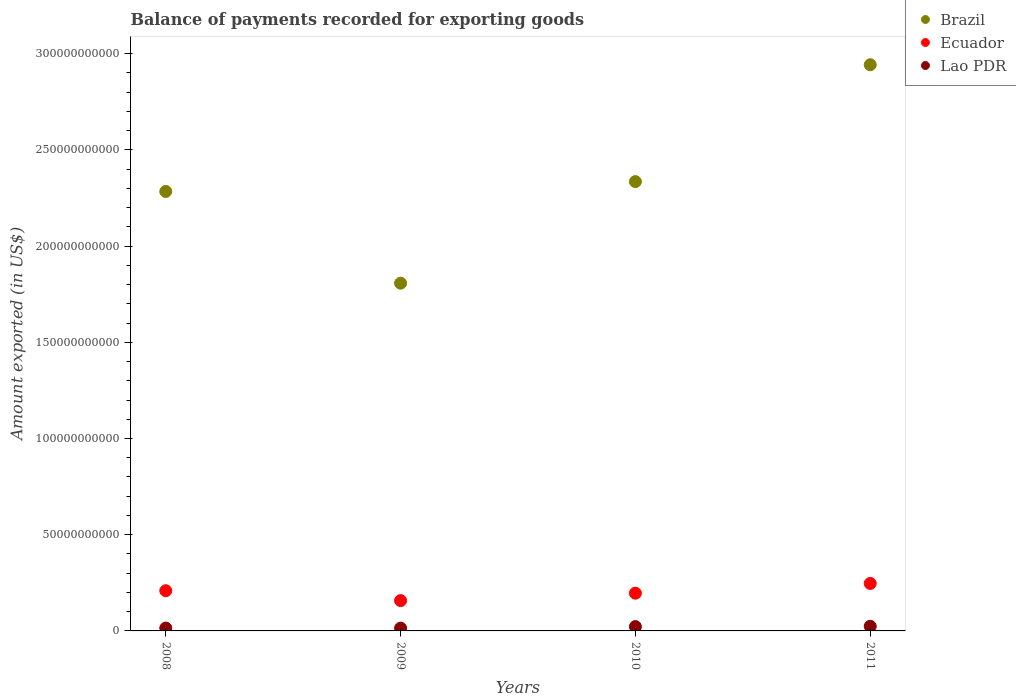Is the number of dotlines equal to the number of legend labels?
Make the answer very short. Yes. What is the amount exported in Lao PDR in 2011?
Ensure brevity in your answer.  2.40e+09. Across all years, what is the maximum amount exported in Brazil?
Your answer should be very brief. 2.94e+11. Across all years, what is the minimum amount exported in Ecuador?
Ensure brevity in your answer.  1.57e+1. In which year was the amount exported in Lao PDR minimum?
Provide a short and direct response. 2009. What is the total amount exported in Lao PDR in the graph?
Your answer should be compact. 7.60e+09. What is the difference between the amount exported in Brazil in 2009 and that in 2011?
Your answer should be very brief. -1.14e+11. What is the difference between the amount exported in Lao PDR in 2009 and the amount exported in Ecuador in 2008?
Keep it short and to the point. -1.95e+1. What is the average amount exported in Brazil per year?
Your response must be concise. 2.34e+11. In the year 2009, what is the difference between the amount exported in Ecuador and amount exported in Lao PDR?
Your response must be concise. 1.43e+1. What is the ratio of the amount exported in Ecuador in 2008 to that in 2010?
Give a very brief answer. 1.07. Is the amount exported in Lao PDR in 2010 less than that in 2011?
Give a very brief answer. Yes. What is the difference between the highest and the second highest amount exported in Ecuador?
Provide a short and direct response. 3.77e+09. What is the difference between the highest and the lowest amount exported in Ecuador?
Make the answer very short. 8.92e+09. Is the sum of the amount exported in Brazil in 2008 and 2011 greater than the maximum amount exported in Lao PDR across all years?
Provide a short and direct response. Yes. Does the amount exported in Brazil monotonically increase over the years?
Make the answer very short. No. Is the amount exported in Brazil strictly less than the amount exported in Lao PDR over the years?
Offer a terse response. No. How many dotlines are there?
Provide a short and direct response. 3. How many years are there in the graph?
Offer a very short reply. 4. Are the values on the major ticks of Y-axis written in scientific E-notation?
Ensure brevity in your answer.  No. Does the graph contain grids?
Provide a succinct answer. No. Where does the legend appear in the graph?
Your answer should be very brief. Top right. How many legend labels are there?
Offer a very short reply. 3. What is the title of the graph?
Keep it short and to the point. Balance of payments recorded for exporting goods. Does "Myanmar" appear as one of the legend labels in the graph?
Your response must be concise. No. What is the label or title of the Y-axis?
Offer a very short reply. Amount exported (in US$). What is the Amount exported (in US$) in Brazil in 2008?
Keep it short and to the point. 2.28e+11. What is the Amount exported (in US$) in Ecuador in 2008?
Give a very brief answer. 2.09e+1. What is the Amount exported (in US$) in Lao PDR in 2008?
Offer a very short reply. 1.49e+09. What is the Amount exported (in US$) in Brazil in 2009?
Provide a short and direct response. 1.81e+11. What is the Amount exported (in US$) in Ecuador in 2009?
Keep it short and to the point. 1.57e+1. What is the Amount exported (in US$) in Lao PDR in 2009?
Keep it short and to the point. 1.45e+09. What is the Amount exported (in US$) in Brazil in 2010?
Provide a succinct answer. 2.34e+11. What is the Amount exported (in US$) in Ecuador in 2010?
Provide a succinct answer. 1.96e+1. What is the Amount exported (in US$) in Lao PDR in 2010?
Your answer should be very brief. 2.26e+09. What is the Amount exported (in US$) in Brazil in 2011?
Your response must be concise. 2.94e+11. What is the Amount exported (in US$) in Ecuador in 2011?
Your answer should be very brief. 2.47e+1. What is the Amount exported (in US$) of Lao PDR in 2011?
Ensure brevity in your answer.  2.40e+09. Across all years, what is the maximum Amount exported (in US$) in Brazil?
Offer a very short reply. 2.94e+11. Across all years, what is the maximum Amount exported (in US$) of Ecuador?
Your response must be concise. 2.47e+1. Across all years, what is the maximum Amount exported (in US$) in Lao PDR?
Offer a terse response. 2.40e+09. Across all years, what is the minimum Amount exported (in US$) in Brazil?
Offer a terse response. 1.81e+11. Across all years, what is the minimum Amount exported (in US$) in Ecuador?
Your answer should be compact. 1.57e+1. Across all years, what is the minimum Amount exported (in US$) in Lao PDR?
Provide a succinct answer. 1.45e+09. What is the total Amount exported (in US$) in Brazil in the graph?
Your answer should be compact. 9.37e+11. What is the total Amount exported (in US$) of Ecuador in the graph?
Ensure brevity in your answer.  8.09e+1. What is the total Amount exported (in US$) in Lao PDR in the graph?
Your answer should be very brief. 7.60e+09. What is the difference between the Amount exported (in US$) of Brazil in 2008 and that in 2009?
Make the answer very short. 4.77e+1. What is the difference between the Amount exported (in US$) in Ecuador in 2008 and that in 2009?
Keep it short and to the point. 5.15e+09. What is the difference between the Amount exported (in US$) of Lao PDR in 2008 and that in 2009?
Your answer should be very brief. 4.36e+07. What is the difference between the Amount exported (in US$) of Brazil in 2008 and that in 2010?
Your answer should be very brief. -5.12e+09. What is the difference between the Amount exported (in US$) of Ecuador in 2008 and that in 2010?
Give a very brief answer. 1.29e+09. What is the difference between the Amount exported (in US$) in Lao PDR in 2008 and that in 2010?
Give a very brief answer. -7.64e+08. What is the difference between the Amount exported (in US$) of Brazil in 2008 and that in 2011?
Your answer should be compact. -6.59e+1. What is the difference between the Amount exported (in US$) of Ecuador in 2008 and that in 2011?
Offer a terse response. -3.77e+09. What is the difference between the Amount exported (in US$) in Lao PDR in 2008 and that in 2011?
Make the answer very short. -9.10e+08. What is the difference between the Amount exported (in US$) of Brazil in 2009 and that in 2010?
Your answer should be compact. -5.28e+1. What is the difference between the Amount exported (in US$) in Ecuador in 2009 and that in 2010?
Your response must be concise. -3.86e+09. What is the difference between the Amount exported (in US$) in Lao PDR in 2009 and that in 2010?
Provide a succinct answer. -8.07e+08. What is the difference between the Amount exported (in US$) of Brazil in 2009 and that in 2011?
Your answer should be compact. -1.14e+11. What is the difference between the Amount exported (in US$) in Ecuador in 2009 and that in 2011?
Your answer should be very brief. -8.92e+09. What is the difference between the Amount exported (in US$) of Lao PDR in 2009 and that in 2011?
Your answer should be compact. -9.54e+08. What is the difference between the Amount exported (in US$) in Brazil in 2010 and that in 2011?
Give a very brief answer. -6.07e+1. What is the difference between the Amount exported (in US$) in Ecuador in 2010 and that in 2011?
Offer a very short reply. -5.06e+09. What is the difference between the Amount exported (in US$) of Lao PDR in 2010 and that in 2011?
Provide a short and direct response. -1.46e+08. What is the difference between the Amount exported (in US$) of Brazil in 2008 and the Amount exported (in US$) of Ecuador in 2009?
Ensure brevity in your answer.  2.13e+11. What is the difference between the Amount exported (in US$) in Brazil in 2008 and the Amount exported (in US$) in Lao PDR in 2009?
Make the answer very short. 2.27e+11. What is the difference between the Amount exported (in US$) in Ecuador in 2008 and the Amount exported (in US$) in Lao PDR in 2009?
Ensure brevity in your answer.  1.95e+1. What is the difference between the Amount exported (in US$) in Brazil in 2008 and the Amount exported (in US$) in Ecuador in 2010?
Provide a short and direct response. 2.09e+11. What is the difference between the Amount exported (in US$) in Brazil in 2008 and the Amount exported (in US$) in Lao PDR in 2010?
Your answer should be compact. 2.26e+11. What is the difference between the Amount exported (in US$) in Ecuador in 2008 and the Amount exported (in US$) in Lao PDR in 2010?
Keep it short and to the point. 1.86e+1. What is the difference between the Amount exported (in US$) of Brazil in 2008 and the Amount exported (in US$) of Ecuador in 2011?
Offer a terse response. 2.04e+11. What is the difference between the Amount exported (in US$) in Brazil in 2008 and the Amount exported (in US$) in Lao PDR in 2011?
Your answer should be compact. 2.26e+11. What is the difference between the Amount exported (in US$) of Ecuador in 2008 and the Amount exported (in US$) of Lao PDR in 2011?
Offer a terse response. 1.85e+1. What is the difference between the Amount exported (in US$) of Brazil in 2009 and the Amount exported (in US$) of Ecuador in 2010?
Your response must be concise. 1.61e+11. What is the difference between the Amount exported (in US$) of Brazil in 2009 and the Amount exported (in US$) of Lao PDR in 2010?
Ensure brevity in your answer.  1.78e+11. What is the difference between the Amount exported (in US$) of Ecuador in 2009 and the Amount exported (in US$) of Lao PDR in 2010?
Make the answer very short. 1.35e+1. What is the difference between the Amount exported (in US$) of Brazil in 2009 and the Amount exported (in US$) of Ecuador in 2011?
Make the answer very short. 1.56e+11. What is the difference between the Amount exported (in US$) in Brazil in 2009 and the Amount exported (in US$) in Lao PDR in 2011?
Give a very brief answer. 1.78e+11. What is the difference between the Amount exported (in US$) of Ecuador in 2009 and the Amount exported (in US$) of Lao PDR in 2011?
Provide a short and direct response. 1.33e+1. What is the difference between the Amount exported (in US$) of Brazil in 2010 and the Amount exported (in US$) of Ecuador in 2011?
Ensure brevity in your answer.  2.09e+11. What is the difference between the Amount exported (in US$) of Brazil in 2010 and the Amount exported (in US$) of Lao PDR in 2011?
Your answer should be compact. 2.31e+11. What is the difference between the Amount exported (in US$) in Ecuador in 2010 and the Amount exported (in US$) in Lao PDR in 2011?
Make the answer very short. 1.72e+1. What is the average Amount exported (in US$) of Brazil per year?
Give a very brief answer. 2.34e+11. What is the average Amount exported (in US$) of Ecuador per year?
Your answer should be compact. 2.02e+1. What is the average Amount exported (in US$) of Lao PDR per year?
Make the answer very short. 1.90e+09. In the year 2008, what is the difference between the Amount exported (in US$) in Brazil and Amount exported (in US$) in Ecuador?
Offer a terse response. 2.07e+11. In the year 2008, what is the difference between the Amount exported (in US$) in Brazil and Amount exported (in US$) in Lao PDR?
Your response must be concise. 2.27e+11. In the year 2008, what is the difference between the Amount exported (in US$) of Ecuador and Amount exported (in US$) of Lao PDR?
Your response must be concise. 1.94e+1. In the year 2009, what is the difference between the Amount exported (in US$) in Brazil and Amount exported (in US$) in Ecuador?
Provide a short and direct response. 1.65e+11. In the year 2009, what is the difference between the Amount exported (in US$) in Brazil and Amount exported (in US$) in Lao PDR?
Keep it short and to the point. 1.79e+11. In the year 2009, what is the difference between the Amount exported (in US$) of Ecuador and Amount exported (in US$) of Lao PDR?
Provide a short and direct response. 1.43e+1. In the year 2010, what is the difference between the Amount exported (in US$) in Brazil and Amount exported (in US$) in Ecuador?
Ensure brevity in your answer.  2.14e+11. In the year 2010, what is the difference between the Amount exported (in US$) in Brazil and Amount exported (in US$) in Lao PDR?
Make the answer very short. 2.31e+11. In the year 2010, what is the difference between the Amount exported (in US$) in Ecuador and Amount exported (in US$) in Lao PDR?
Your response must be concise. 1.74e+1. In the year 2011, what is the difference between the Amount exported (in US$) in Brazil and Amount exported (in US$) in Ecuador?
Keep it short and to the point. 2.70e+11. In the year 2011, what is the difference between the Amount exported (in US$) in Brazil and Amount exported (in US$) in Lao PDR?
Give a very brief answer. 2.92e+11. In the year 2011, what is the difference between the Amount exported (in US$) in Ecuador and Amount exported (in US$) in Lao PDR?
Keep it short and to the point. 2.23e+1. What is the ratio of the Amount exported (in US$) of Brazil in 2008 to that in 2009?
Your answer should be compact. 1.26. What is the ratio of the Amount exported (in US$) of Ecuador in 2008 to that in 2009?
Your answer should be very brief. 1.33. What is the ratio of the Amount exported (in US$) in Lao PDR in 2008 to that in 2009?
Provide a short and direct response. 1.03. What is the ratio of the Amount exported (in US$) of Brazil in 2008 to that in 2010?
Keep it short and to the point. 0.98. What is the ratio of the Amount exported (in US$) in Ecuador in 2008 to that in 2010?
Give a very brief answer. 1.07. What is the ratio of the Amount exported (in US$) in Lao PDR in 2008 to that in 2010?
Your response must be concise. 0.66. What is the ratio of the Amount exported (in US$) in Brazil in 2008 to that in 2011?
Give a very brief answer. 0.78. What is the ratio of the Amount exported (in US$) of Ecuador in 2008 to that in 2011?
Provide a short and direct response. 0.85. What is the ratio of the Amount exported (in US$) of Lao PDR in 2008 to that in 2011?
Provide a succinct answer. 0.62. What is the ratio of the Amount exported (in US$) in Brazil in 2009 to that in 2010?
Your answer should be very brief. 0.77. What is the ratio of the Amount exported (in US$) of Ecuador in 2009 to that in 2010?
Keep it short and to the point. 0.8. What is the ratio of the Amount exported (in US$) in Lao PDR in 2009 to that in 2010?
Make the answer very short. 0.64. What is the ratio of the Amount exported (in US$) of Brazil in 2009 to that in 2011?
Give a very brief answer. 0.61. What is the ratio of the Amount exported (in US$) of Ecuador in 2009 to that in 2011?
Provide a short and direct response. 0.64. What is the ratio of the Amount exported (in US$) in Lao PDR in 2009 to that in 2011?
Make the answer very short. 0.6. What is the ratio of the Amount exported (in US$) of Brazil in 2010 to that in 2011?
Provide a succinct answer. 0.79. What is the ratio of the Amount exported (in US$) of Ecuador in 2010 to that in 2011?
Your answer should be very brief. 0.79. What is the ratio of the Amount exported (in US$) in Lao PDR in 2010 to that in 2011?
Keep it short and to the point. 0.94. What is the difference between the highest and the second highest Amount exported (in US$) of Brazil?
Provide a short and direct response. 6.07e+1. What is the difference between the highest and the second highest Amount exported (in US$) of Ecuador?
Offer a terse response. 3.77e+09. What is the difference between the highest and the second highest Amount exported (in US$) in Lao PDR?
Keep it short and to the point. 1.46e+08. What is the difference between the highest and the lowest Amount exported (in US$) of Brazil?
Give a very brief answer. 1.14e+11. What is the difference between the highest and the lowest Amount exported (in US$) of Ecuador?
Your answer should be very brief. 8.92e+09. What is the difference between the highest and the lowest Amount exported (in US$) of Lao PDR?
Your answer should be very brief. 9.54e+08. 